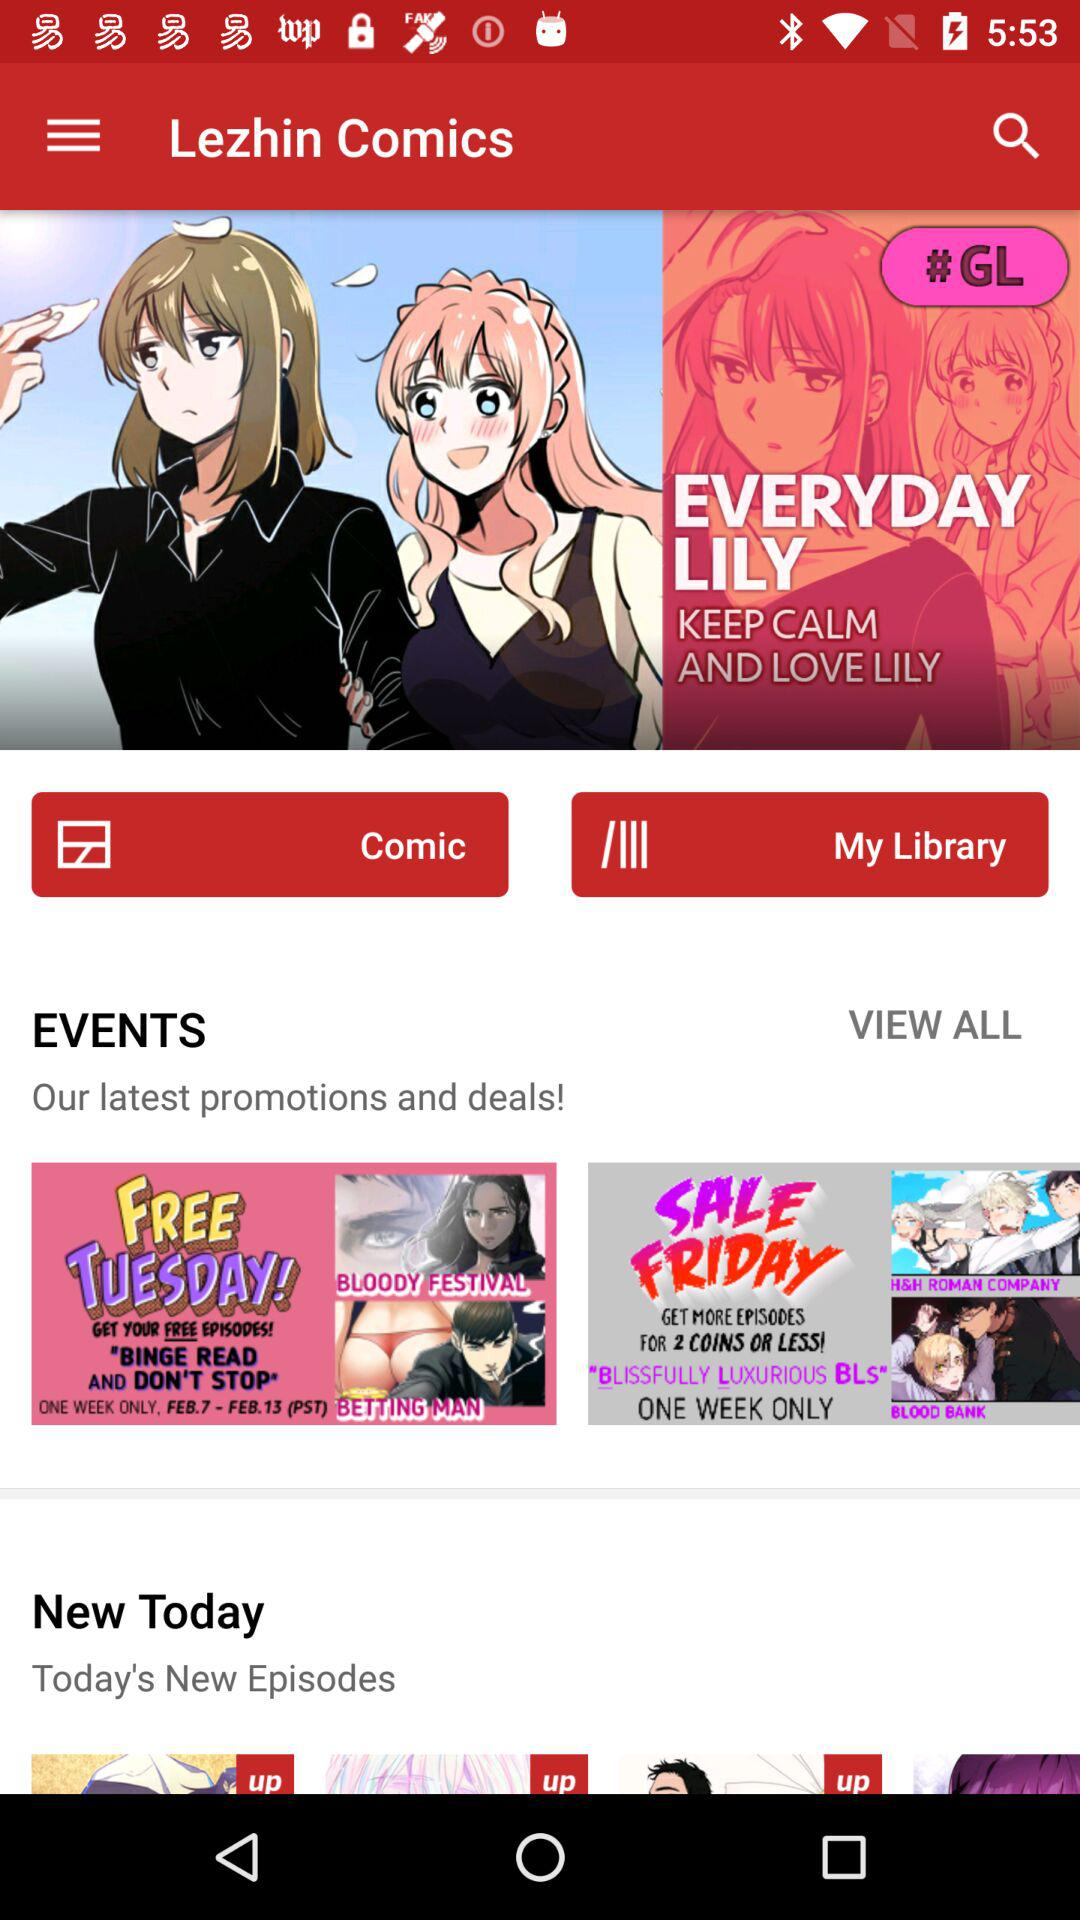What is the comic's title? The comic's titles are "EVERYDAY LILY", "BLOODY FESTIVAL", "BETTING MAN", "H&H ROMAN COMPANY" and "BLOOD BANK". 